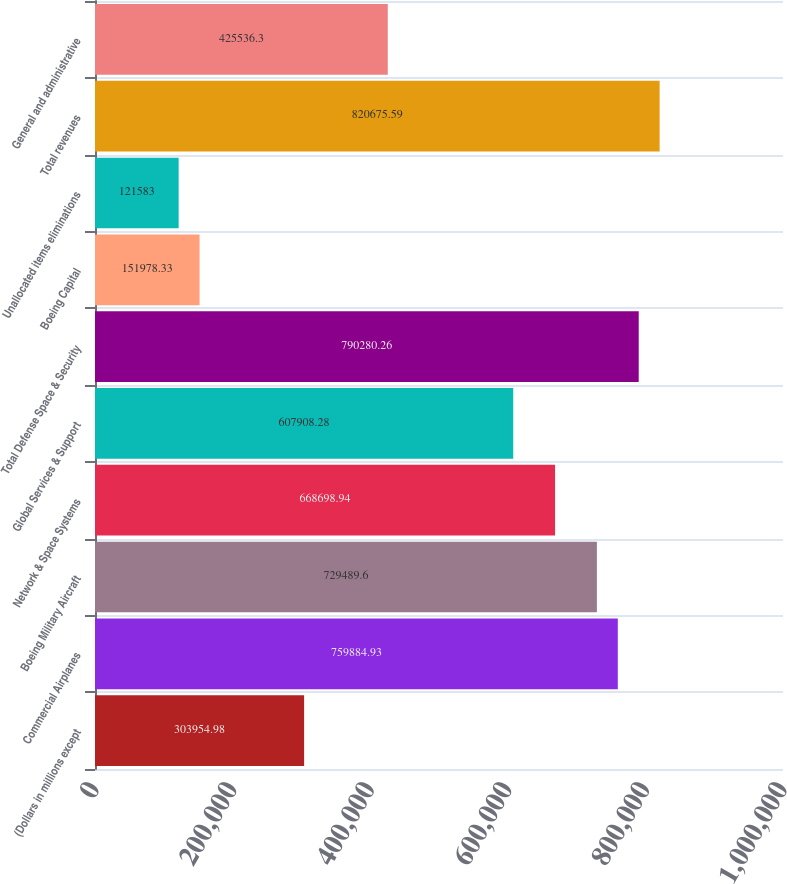<chart> <loc_0><loc_0><loc_500><loc_500><bar_chart><fcel>(Dollars in millions except<fcel>Commercial Airplanes<fcel>Boeing Military Aircraft<fcel>Network & Space Systems<fcel>Global Services & Support<fcel>Total Defense Space & Security<fcel>Boeing Capital<fcel>Unallocated items eliminations<fcel>Total revenues<fcel>General and administrative<nl><fcel>303955<fcel>759885<fcel>729490<fcel>668699<fcel>607908<fcel>790280<fcel>151978<fcel>121583<fcel>820676<fcel>425536<nl></chart> 